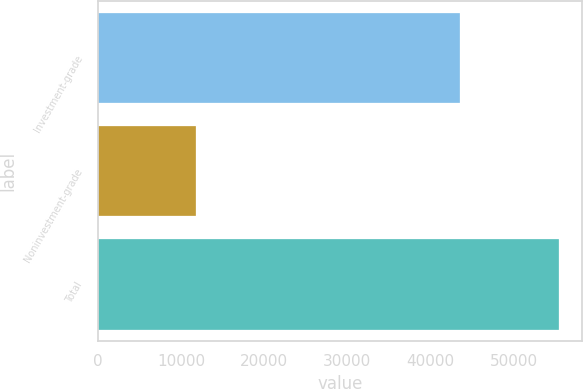Convert chart. <chart><loc_0><loc_0><loc_500><loc_500><bar_chart><fcel>Investment-grade<fcel>Noninvestment-grade<fcel>Total<nl><fcel>43611<fcel>11840<fcel>55451<nl></chart> 